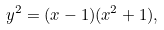<formula> <loc_0><loc_0><loc_500><loc_500>y ^ { 2 } = ( x - 1 ) ( x ^ { 2 } + 1 ) ,</formula> 